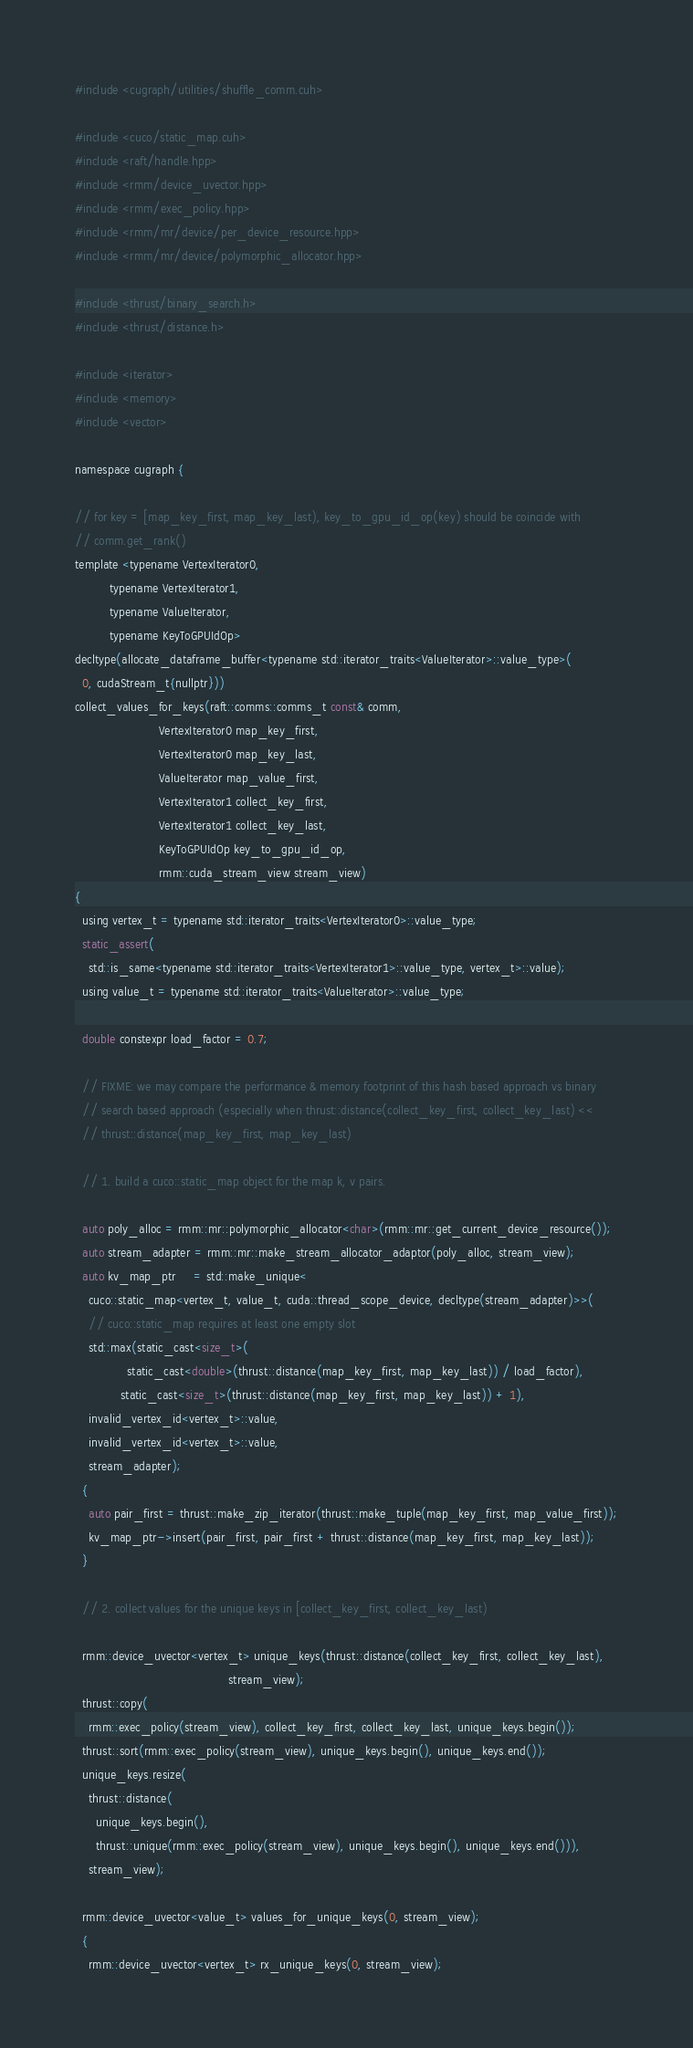<code> <loc_0><loc_0><loc_500><loc_500><_Cuda_>#include <cugraph/utilities/shuffle_comm.cuh>

#include <cuco/static_map.cuh>
#include <raft/handle.hpp>
#include <rmm/device_uvector.hpp>
#include <rmm/exec_policy.hpp>
#include <rmm/mr/device/per_device_resource.hpp>
#include <rmm/mr/device/polymorphic_allocator.hpp>

#include <thrust/binary_search.h>
#include <thrust/distance.h>

#include <iterator>
#include <memory>
#include <vector>

namespace cugraph {

// for key = [map_key_first, map_key_last), key_to_gpu_id_op(key) should be coincide with
// comm.get_rank()
template <typename VertexIterator0,
          typename VertexIterator1,
          typename ValueIterator,
          typename KeyToGPUIdOp>
decltype(allocate_dataframe_buffer<typename std::iterator_traits<ValueIterator>::value_type>(
  0, cudaStream_t{nullptr}))
collect_values_for_keys(raft::comms::comms_t const& comm,
                        VertexIterator0 map_key_first,
                        VertexIterator0 map_key_last,
                        ValueIterator map_value_first,
                        VertexIterator1 collect_key_first,
                        VertexIterator1 collect_key_last,
                        KeyToGPUIdOp key_to_gpu_id_op,
                        rmm::cuda_stream_view stream_view)
{
  using vertex_t = typename std::iterator_traits<VertexIterator0>::value_type;
  static_assert(
    std::is_same<typename std::iterator_traits<VertexIterator1>::value_type, vertex_t>::value);
  using value_t = typename std::iterator_traits<ValueIterator>::value_type;

  double constexpr load_factor = 0.7;

  // FIXME: we may compare the performance & memory footprint of this hash based approach vs binary
  // search based approach (especially when thrust::distance(collect_key_first, collect_key_last) <<
  // thrust::distance(map_key_first, map_key_last)

  // 1. build a cuco::static_map object for the map k, v pairs.

  auto poly_alloc = rmm::mr::polymorphic_allocator<char>(rmm::mr::get_current_device_resource());
  auto stream_adapter = rmm::mr::make_stream_allocator_adaptor(poly_alloc, stream_view);
  auto kv_map_ptr     = std::make_unique<
    cuco::static_map<vertex_t, value_t, cuda::thread_scope_device, decltype(stream_adapter)>>(
    // cuco::static_map requires at least one empty slot
    std::max(static_cast<size_t>(
               static_cast<double>(thrust::distance(map_key_first, map_key_last)) / load_factor),
             static_cast<size_t>(thrust::distance(map_key_first, map_key_last)) + 1),
    invalid_vertex_id<vertex_t>::value,
    invalid_vertex_id<vertex_t>::value,
    stream_adapter);
  {
    auto pair_first = thrust::make_zip_iterator(thrust::make_tuple(map_key_first, map_value_first));
    kv_map_ptr->insert(pair_first, pair_first + thrust::distance(map_key_first, map_key_last));
  }

  // 2. collect values for the unique keys in [collect_key_first, collect_key_last)

  rmm::device_uvector<vertex_t> unique_keys(thrust::distance(collect_key_first, collect_key_last),
                                            stream_view);
  thrust::copy(
    rmm::exec_policy(stream_view), collect_key_first, collect_key_last, unique_keys.begin());
  thrust::sort(rmm::exec_policy(stream_view), unique_keys.begin(), unique_keys.end());
  unique_keys.resize(
    thrust::distance(
      unique_keys.begin(),
      thrust::unique(rmm::exec_policy(stream_view), unique_keys.begin(), unique_keys.end())),
    stream_view);

  rmm::device_uvector<value_t> values_for_unique_keys(0, stream_view);
  {
    rmm::device_uvector<vertex_t> rx_unique_keys(0, stream_view);</code> 